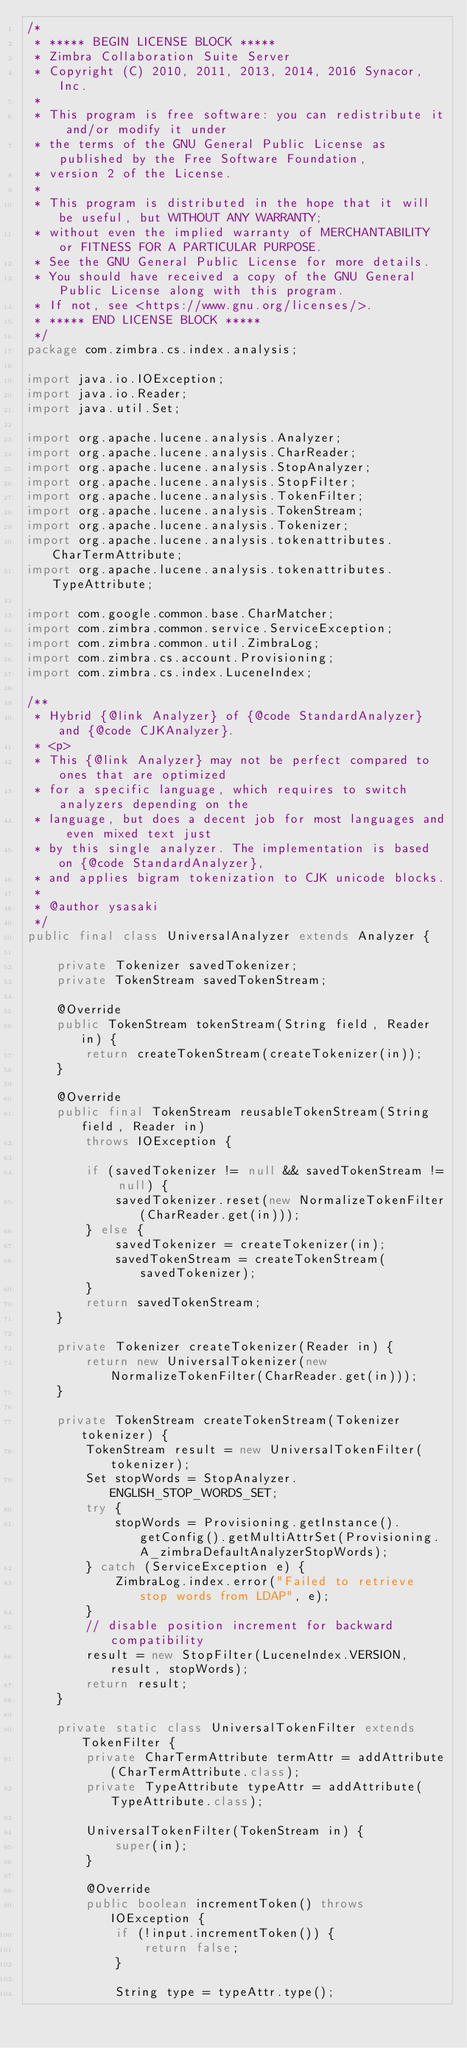Convert code to text. <code><loc_0><loc_0><loc_500><loc_500><_Java_>/*
 * ***** BEGIN LICENSE BLOCK *****
 * Zimbra Collaboration Suite Server
 * Copyright (C) 2010, 2011, 2013, 2014, 2016 Synacor, Inc.
 *
 * This program is free software: you can redistribute it and/or modify it under
 * the terms of the GNU General Public License as published by the Free Software Foundation,
 * version 2 of the License.
 *
 * This program is distributed in the hope that it will be useful, but WITHOUT ANY WARRANTY;
 * without even the implied warranty of MERCHANTABILITY or FITNESS FOR A PARTICULAR PURPOSE.
 * See the GNU General Public License for more details.
 * You should have received a copy of the GNU General Public License along with this program.
 * If not, see <https://www.gnu.org/licenses/>.
 * ***** END LICENSE BLOCK *****
 */
package com.zimbra.cs.index.analysis;

import java.io.IOException;
import java.io.Reader;
import java.util.Set;

import org.apache.lucene.analysis.Analyzer;
import org.apache.lucene.analysis.CharReader;
import org.apache.lucene.analysis.StopAnalyzer;
import org.apache.lucene.analysis.StopFilter;
import org.apache.lucene.analysis.TokenFilter;
import org.apache.lucene.analysis.TokenStream;
import org.apache.lucene.analysis.Tokenizer;
import org.apache.lucene.analysis.tokenattributes.CharTermAttribute;
import org.apache.lucene.analysis.tokenattributes.TypeAttribute;

import com.google.common.base.CharMatcher;
import com.zimbra.common.service.ServiceException;
import com.zimbra.common.util.ZimbraLog;
import com.zimbra.cs.account.Provisioning;
import com.zimbra.cs.index.LuceneIndex;

/**
 * Hybrid {@link Analyzer} of {@code StandardAnalyzer} and {@code CJKAnalyzer}.
 * <p>
 * This {@link Analyzer} may not be perfect compared to ones that are optimized
 * for a specific language, which requires to switch analyzers depending on the
 * language, but does a decent job for most languages and even mixed text just
 * by this single analyzer. The implementation is based on {@code StandardAnalyzer},
 * and applies bigram tokenization to CJK unicode blocks.
 *
 * @author ysasaki
 */
public final class UniversalAnalyzer extends Analyzer {

    private Tokenizer savedTokenizer;
    private TokenStream savedTokenStream;

    @Override
    public TokenStream tokenStream(String field, Reader in) {
        return createTokenStream(createTokenizer(in));
    }

    @Override
    public final TokenStream reusableTokenStream(String field, Reader in)
        throws IOException {

        if (savedTokenizer != null && savedTokenStream != null) {
            savedTokenizer.reset(new NormalizeTokenFilter(CharReader.get(in)));
        } else {
            savedTokenizer = createTokenizer(in);
            savedTokenStream = createTokenStream(savedTokenizer);
        }
        return savedTokenStream;
    }

    private Tokenizer createTokenizer(Reader in) {
        return new UniversalTokenizer(new NormalizeTokenFilter(CharReader.get(in)));
    }

    private TokenStream createTokenStream(Tokenizer tokenizer) {
        TokenStream result = new UniversalTokenFilter(tokenizer);
        Set stopWords = StopAnalyzer.ENGLISH_STOP_WORDS_SET;
        try {
        	stopWords = Provisioning.getInstance().getConfig().getMultiAttrSet(Provisioning.A_zimbraDefaultAnalyzerStopWords);
        } catch (ServiceException e) {
        	ZimbraLog.index.error("Failed to retrieve stop words from LDAP", e);
        }
        // disable position increment for backward compatibility
        result = new StopFilter(LuceneIndex.VERSION, result, stopWords);
        return result;
    }

    private static class UniversalTokenFilter extends TokenFilter {
        private CharTermAttribute termAttr = addAttribute(CharTermAttribute.class);
        private TypeAttribute typeAttr = addAttribute(TypeAttribute.class);

        UniversalTokenFilter(TokenStream in) {
            super(in);
        }

        @Override
        public boolean incrementToken() throws IOException {
            if (!input.incrementToken()) {
                return false;
            }

            String type = typeAttr.type();</code> 